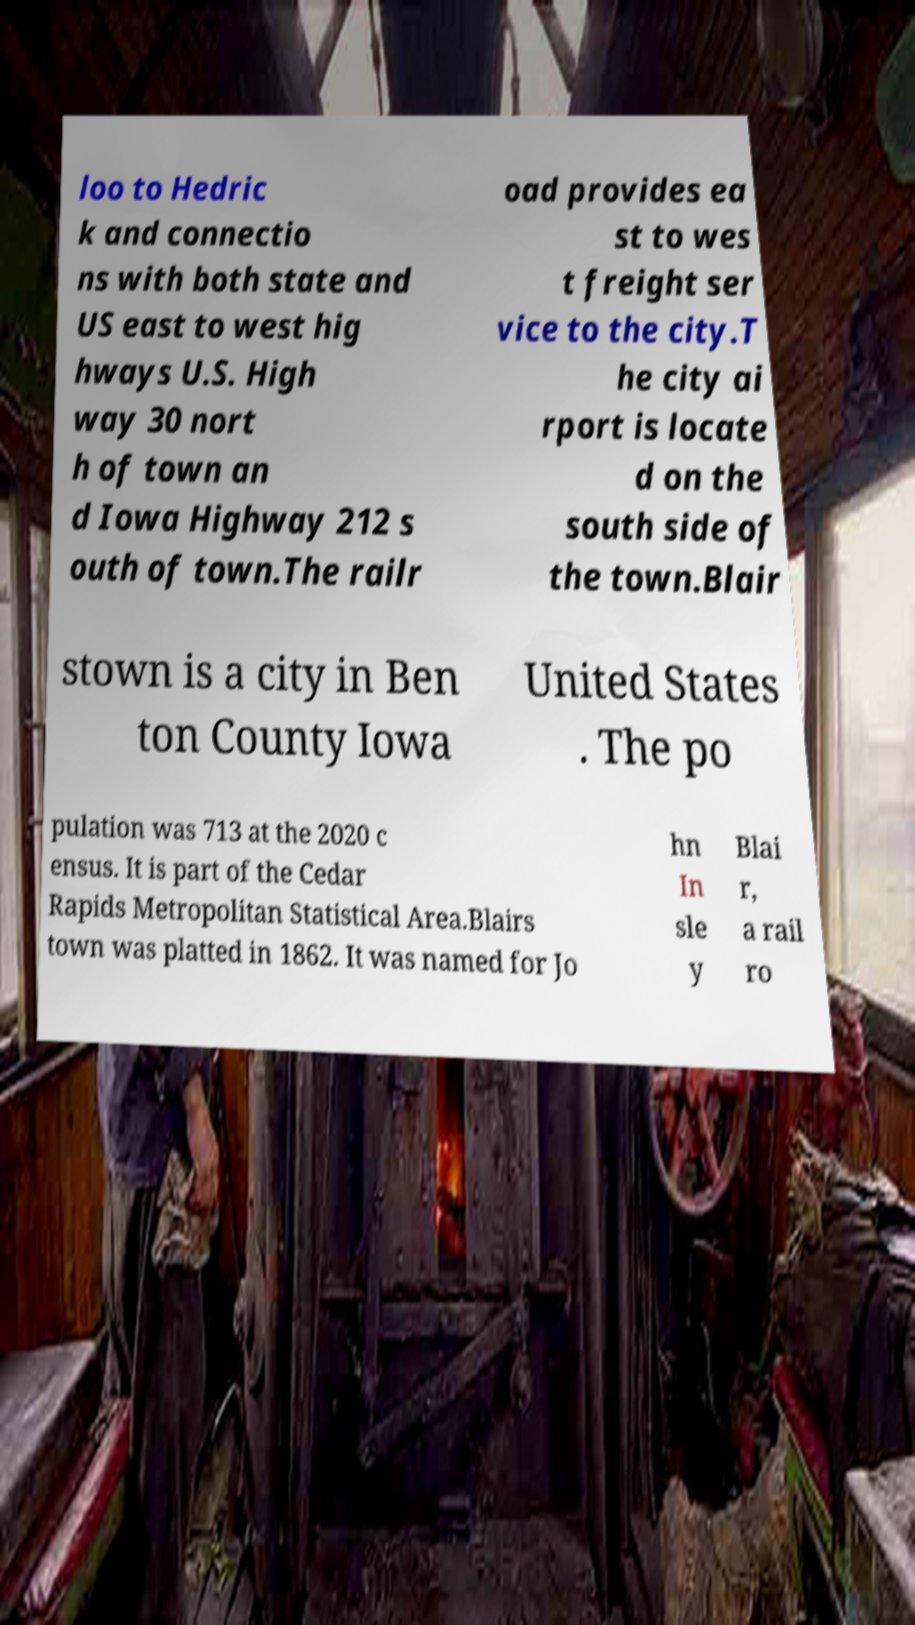I need the written content from this picture converted into text. Can you do that? loo to Hedric k and connectio ns with both state and US east to west hig hways U.S. High way 30 nort h of town an d Iowa Highway 212 s outh of town.The railr oad provides ea st to wes t freight ser vice to the city.T he city ai rport is locate d on the south side of the town.Blair stown is a city in Ben ton County Iowa United States . The po pulation was 713 at the 2020 c ensus. It is part of the Cedar Rapids Metropolitan Statistical Area.Blairs town was platted in 1862. It was named for Jo hn In sle y Blai r, a rail ro 